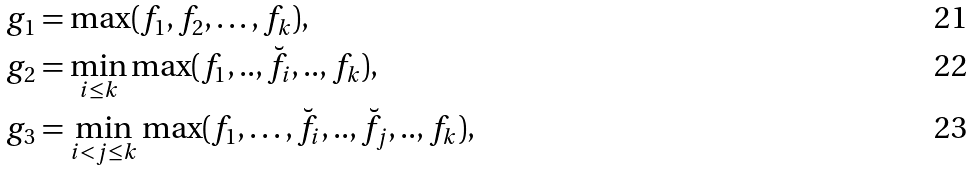<formula> <loc_0><loc_0><loc_500><loc_500>g _ { 1 } & = \max ( f _ { 1 } , f _ { 2 } , \dots , f _ { k } ) , \\ g _ { 2 } & = \min _ { i \leq k } \max ( f _ { 1 } , . . , \breve { f _ { i } } , . . , f _ { k } ) , \\ g _ { 3 } & = \min _ { i < j \leq k } \max ( f _ { 1 } , \dots , \breve { f _ { i } } , . . , \breve { f _ { j } } , . . , f _ { k } ) ,</formula> 